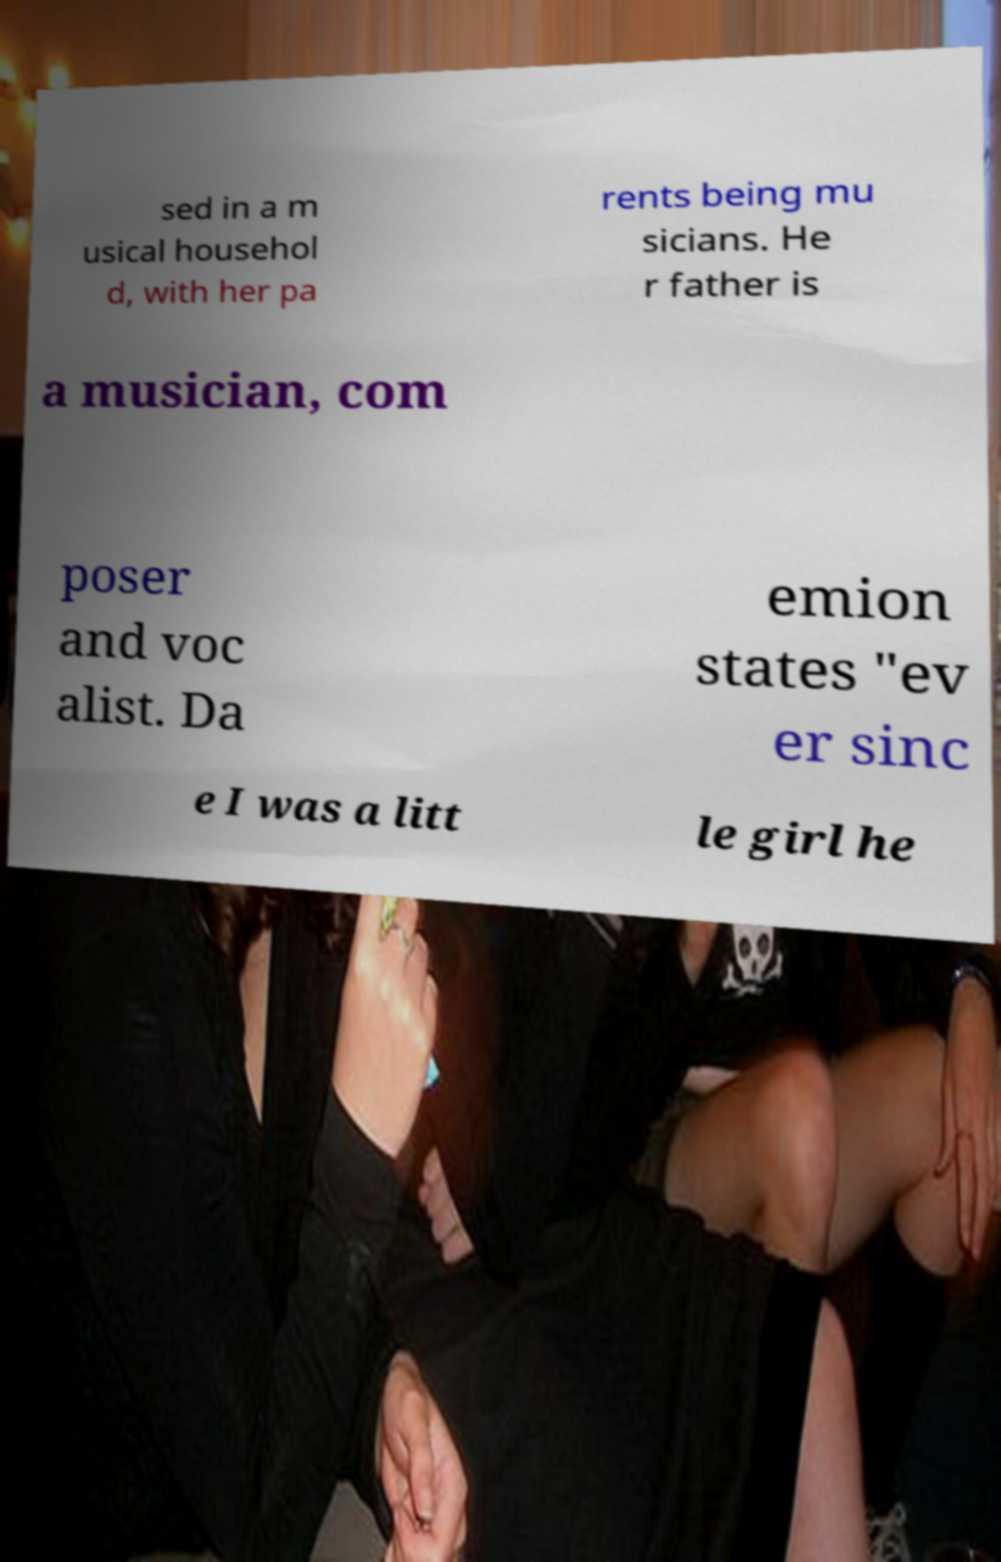Can you read and provide the text displayed in the image?This photo seems to have some interesting text. Can you extract and type it out for me? sed in a m usical househol d, with her pa rents being mu sicians. He r father is a musician, com poser and voc alist. Da emion states "ev er sinc e I was a litt le girl he 